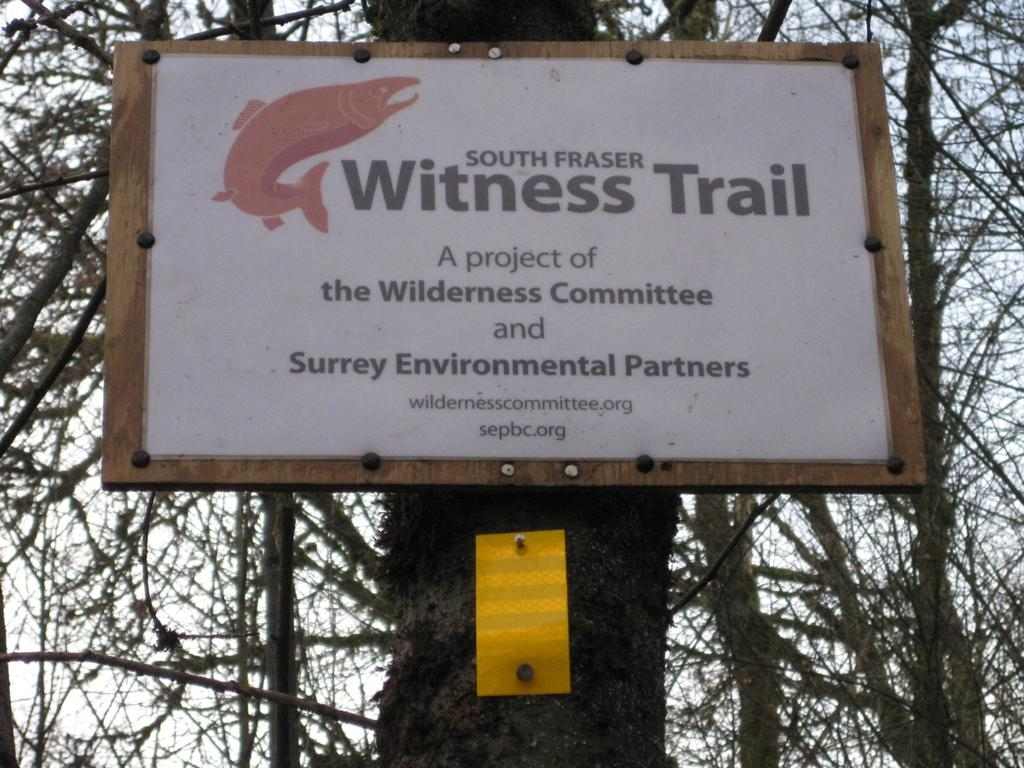What is the main object in the foreground of the image? There is a tree in the image. What is attached to the tree? There is a board on the tree. What can be seen in the background of the image? There are trees and the sky visible in the background of the image. What type of humor can be seen on the board attached to the tree in the image? There is no humor present on the board attached to the tree in the image. Can you tell me where the playground is located in the image? There is no playground present in the image. 